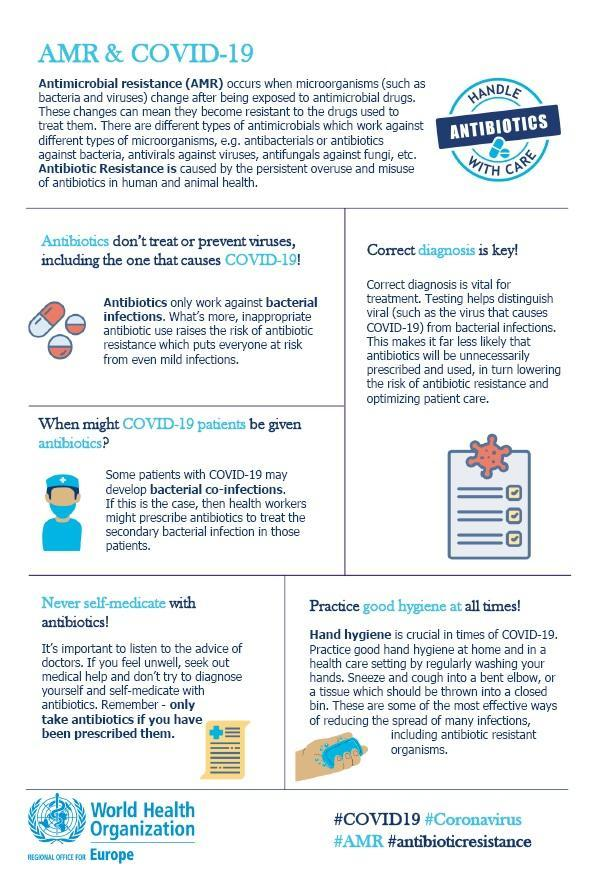What is the name of the anti microbial drug which is used to treat virus?
Answer the question with a short phrase. Antivirus Which is the best practice to fight against Corona Virus? Hand Hygiene 